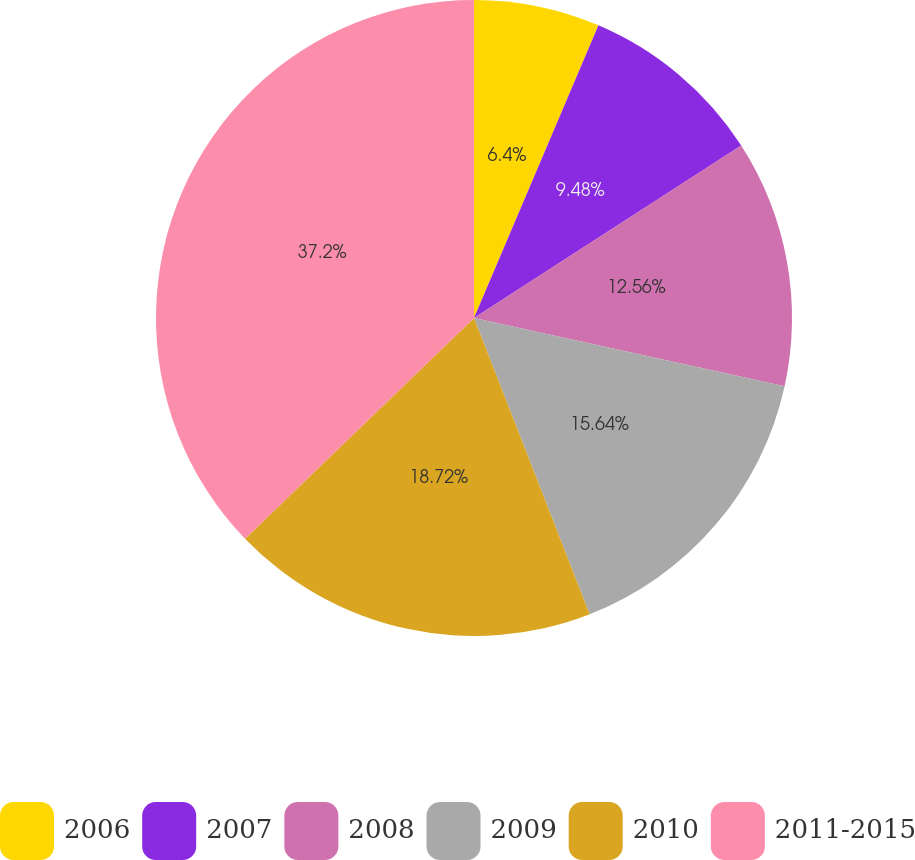<chart> <loc_0><loc_0><loc_500><loc_500><pie_chart><fcel>2006<fcel>2007<fcel>2008<fcel>2009<fcel>2010<fcel>2011-2015<nl><fcel>6.4%<fcel>9.48%<fcel>12.56%<fcel>15.64%<fcel>18.72%<fcel>37.21%<nl></chart> 